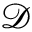<formula> <loc_0><loc_0><loc_500><loc_500>\ m a t h s c r { D }</formula> 